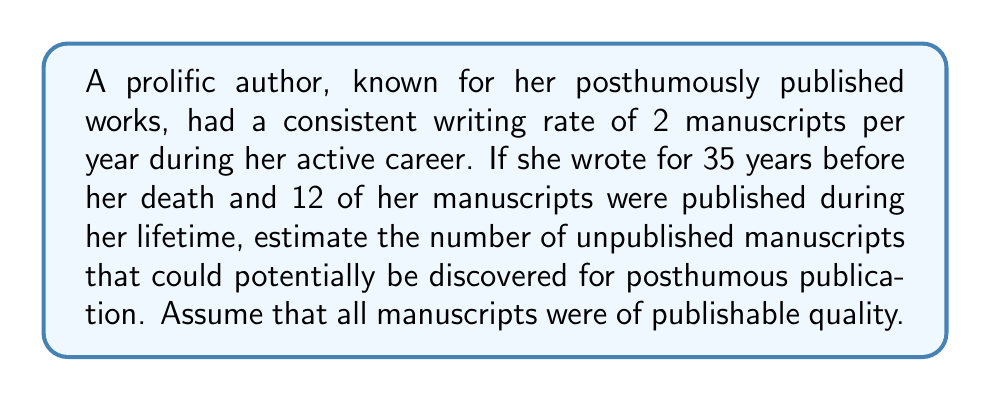Show me your answer to this math problem. To solve this problem, we need to follow these steps:

1. Calculate the total number of manuscripts written:
   Let $r$ be the writing rate per year and $y$ be the number of years.
   Total manuscripts = $r \times y$
   $$ \text{Total manuscripts} = 2 \times 35 = 70 $$

2. Subtract the number of manuscripts published during her lifetime:
   Let $p$ be the number of published manuscripts.
   Unpublished manuscripts = Total manuscripts $-$ Published manuscripts
   $$ \text{Unpublished manuscripts} = 70 - 12 = 58 $$

Therefore, the estimated number of unpublished manuscripts that could potentially be discovered for posthumous publication is 58.

This calculation assumes that:
a) The author maintained a consistent writing rate throughout her career.
b) All manuscripts were preserved and are potentially discoverable.
c) The quality of all manuscripts is suitable for publication.

As a book critic specializing in posthumous works, this estimate provides a valuable insight into the potential literary legacy of the author and the scope for future publications and critical analysis.
Answer: 58 unpublished manuscripts 